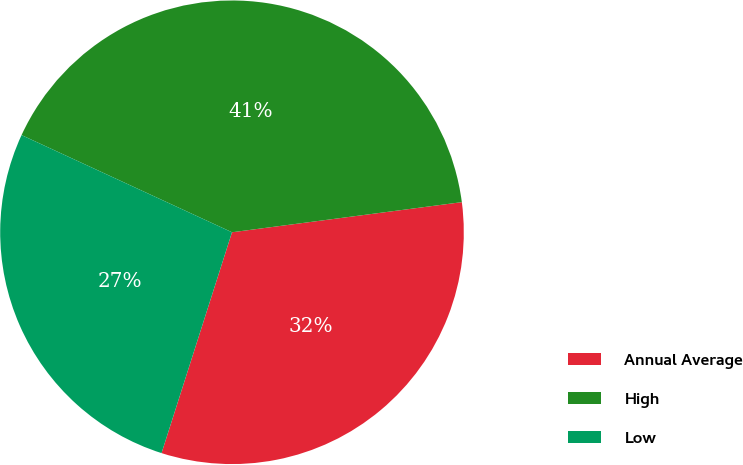Convert chart. <chart><loc_0><loc_0><loc_500><loc_500><pie_chart><fcel>Annual Average<fcel>High<fcel>Low<nl><fcel>31.99%<fcel>41.04%<fcel>26.97%<nl></chart> 